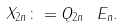<formula> <loc_0><loc_0><loc_500><loc_500>X _ { 2 n } \colon = Q _ { 2 n } \ E _ { n } .</formula> 